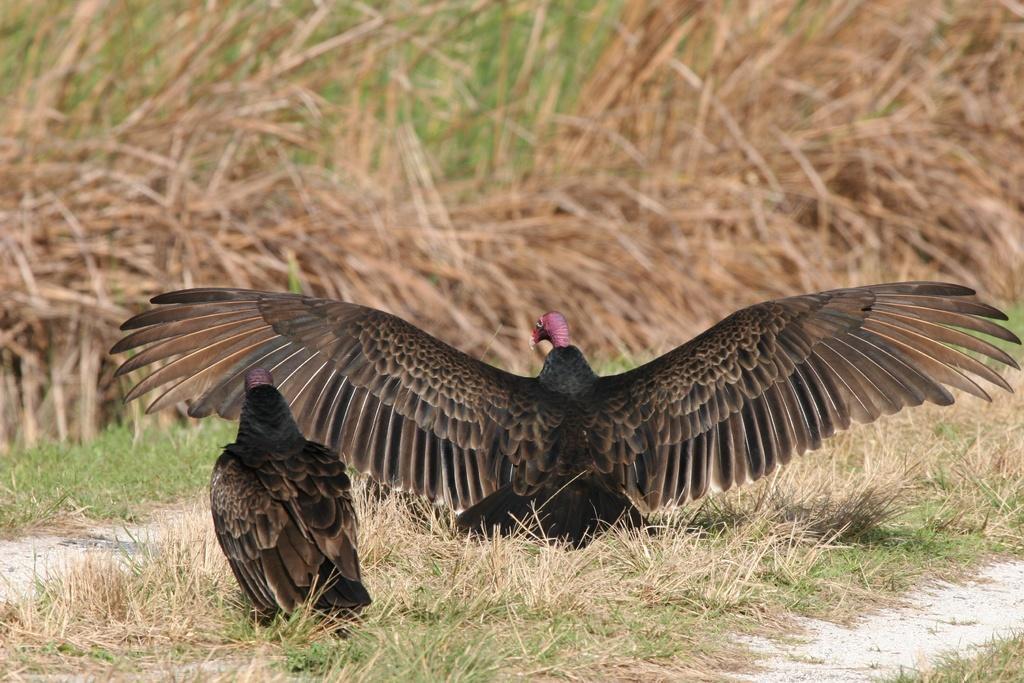Please provide a concise description of this image. There are two turkey vultures standing. These are the wings. I can see the dried grass. In the background, I think these are the dried plants. 